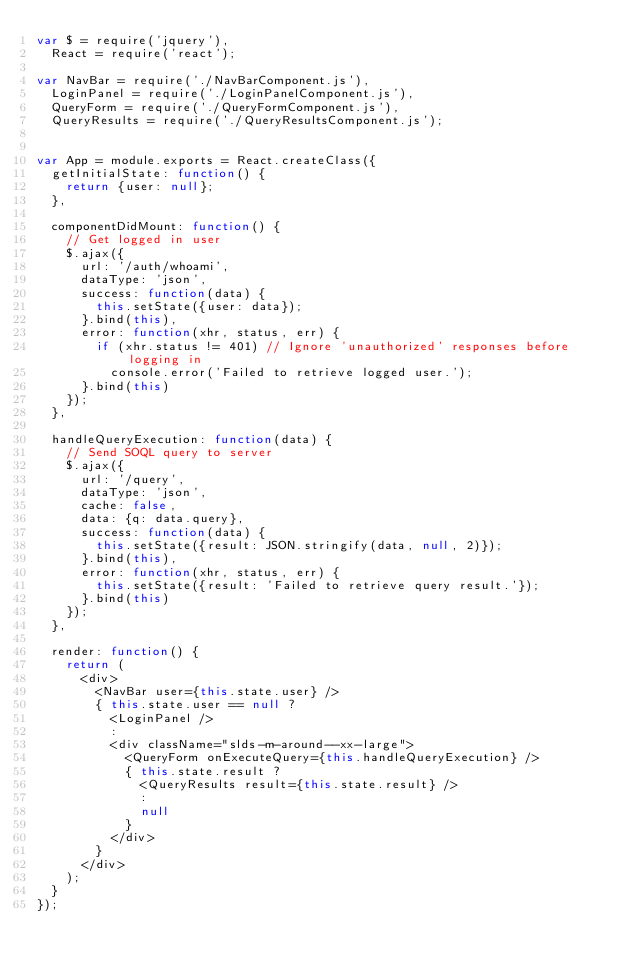<code> <loc_0><loc_0><loc_500><loc_500><_JavaScript_>var $ = require('jquery'),
  React = require('react');

var NavBar = require('./NavBarComponent.js'),
  LoginPanel = require('./LoginPanelComponent.js'),
  QueryForm = require('./QueryFormComponent.js'),
  QueryResults = require('./QueryResultsComponent.js');


var App = module.exports = React.createClass({
  getInitialState: function() {
    return {user: null};
  },

  componentDidMount: function() {
    // Get logged in user
    $.ajax({
      url: '/auth/whoami',
      dataType: 'json',
      success: function(data) {
        this.setState({user: data});
      }.bind(this),
      error: function(xhr, status, err) {
        if (xhr.status != 401) // Ignore 'unauthorized' responses before logging in
          console.error('Failed to retrieve logged user.');
      }.bind(this)
    });
  },

  handleQueryExecution: function(data) {
    // Send SOQL query to server
    $.ajax({
      url: '/query',
      dataType: 'json',
      cache: false,
      data: {q: data.query},
      success: function(data) {
        this.setState({result: JSON.stringify(data, null, 2)});
      }.bind(this),
      error: function(xhr, status, err) {
        this.setState({result: 'Failed to retrieve query result.'});
      }.bind(this)
    });
  },

  render: function() {
    return (
      <div>
        <NavBar user={this.state.user} />
        { this.state.user == null ?
          <LoginPanel />
          :
          <div className="slds-m-around--xx-large">
            <QueryForm onExecuteQuery={this.handleQueryExecution} />
            { this.state.result ?
              <QueryResults result={this.state.result} />
              :
              null
            }
          </div>
        }
      </div>
    );
  }
});
</code> 